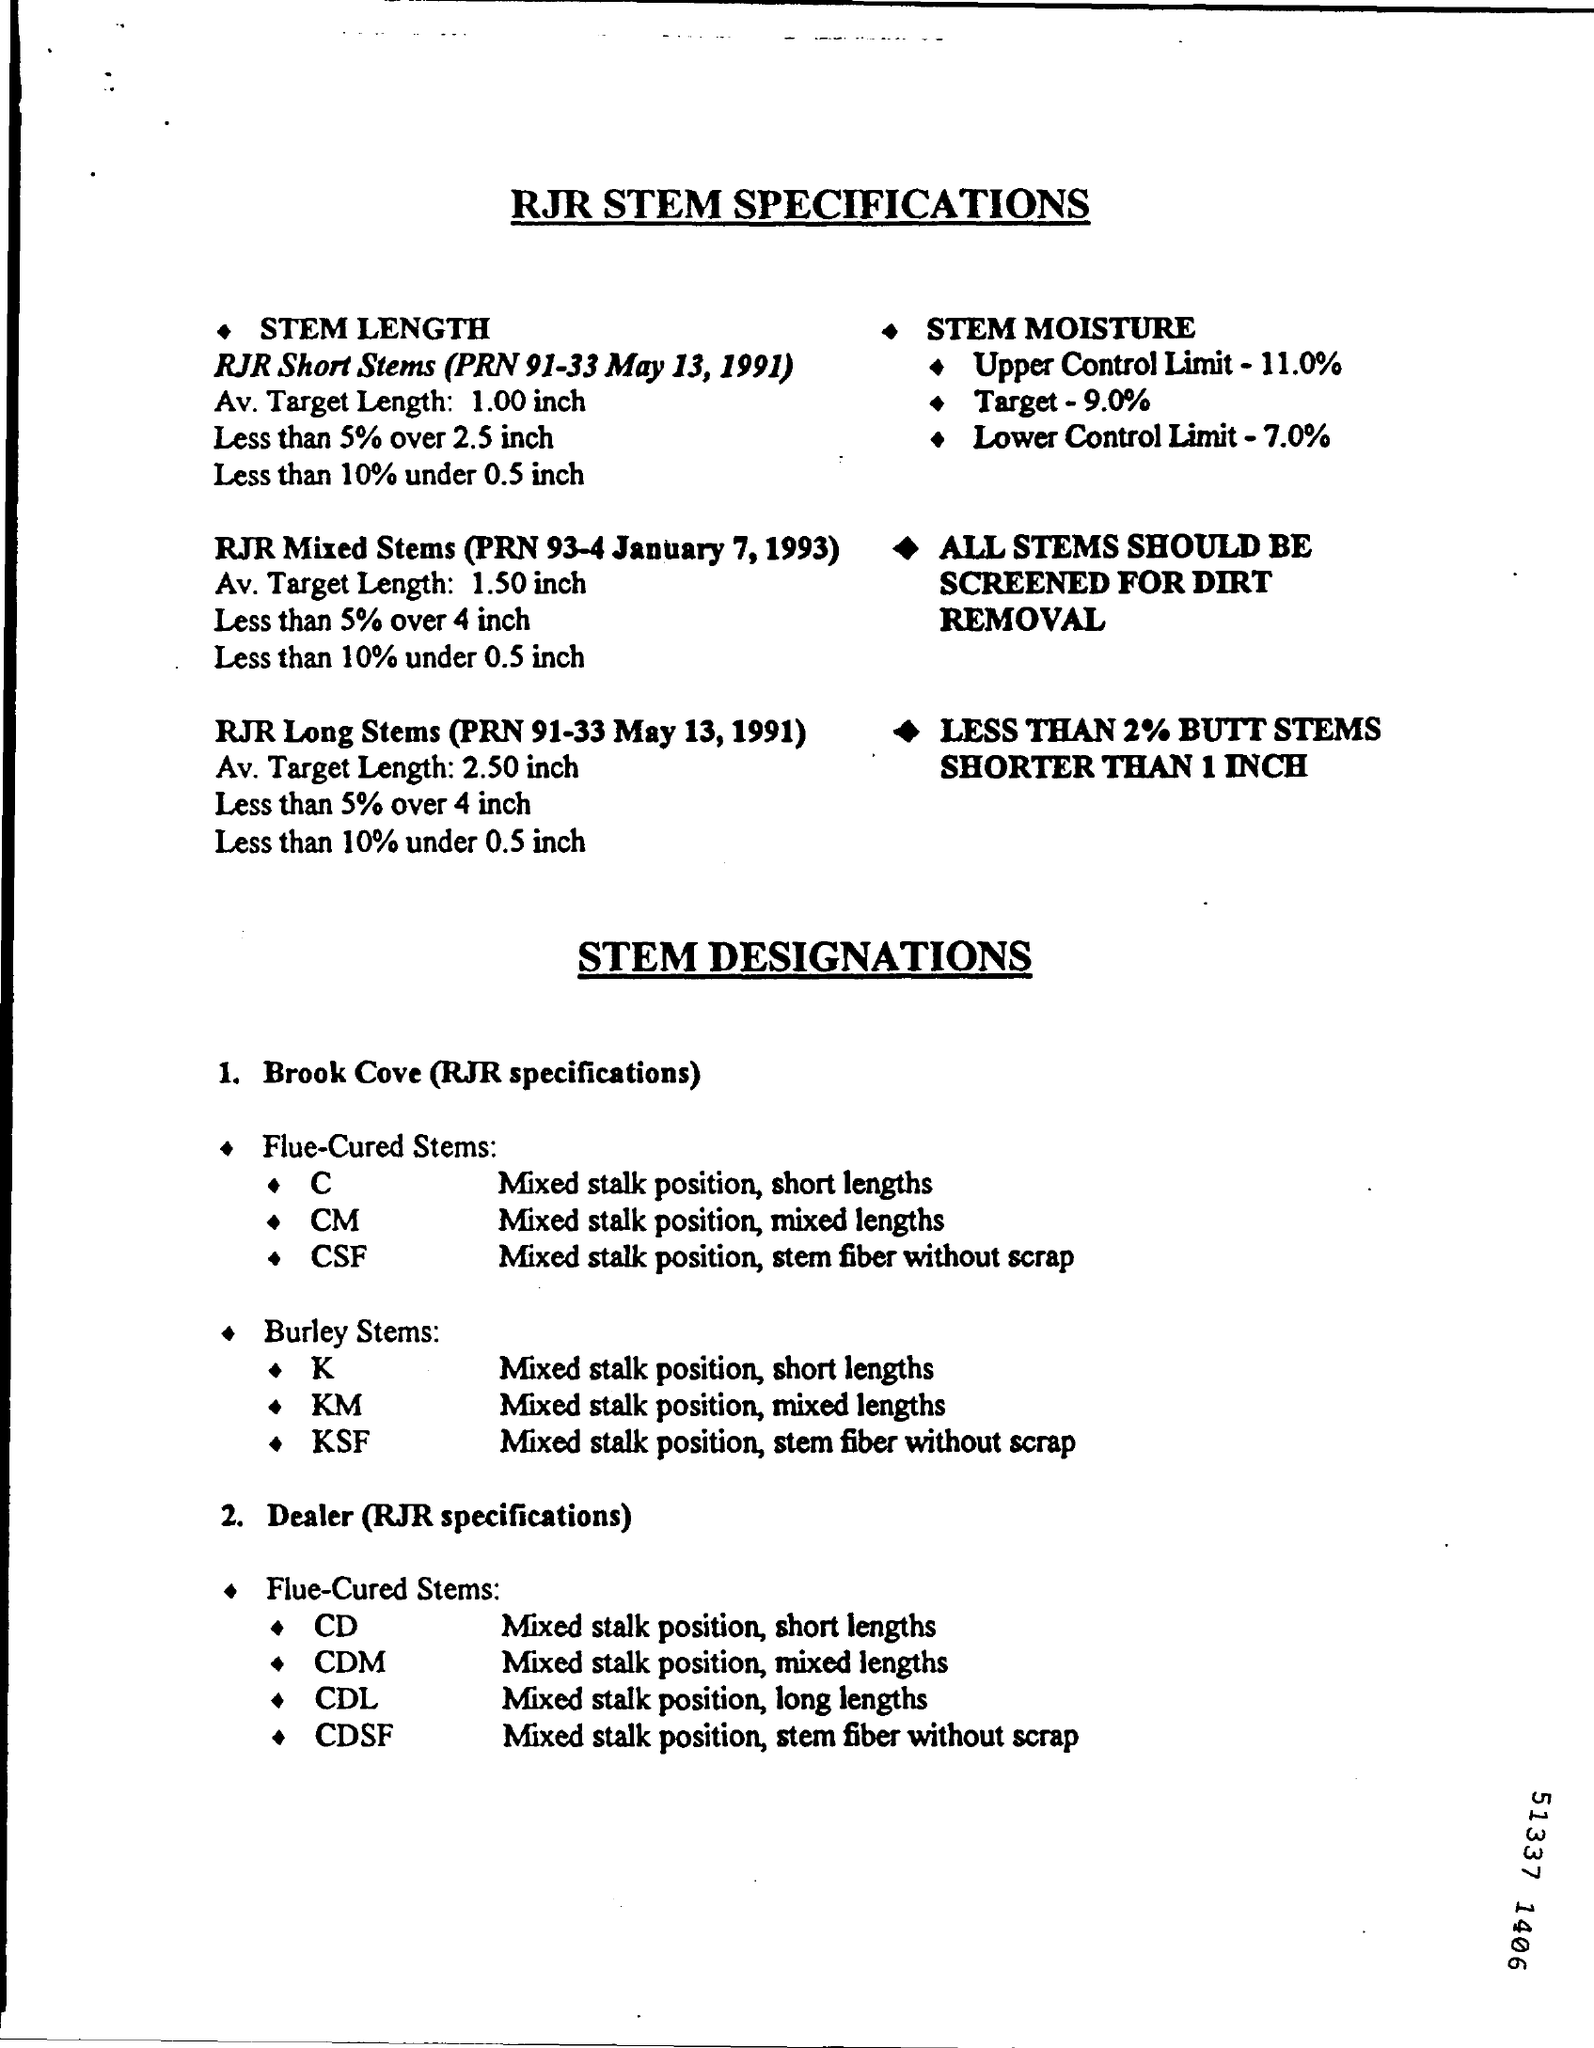What is the document title?
Offer a very short reply. RJR stem specifications. What was the Upper Control Limit of STEM MOISTURE?
Offer a terse response. 11.0%. What is the RJR specification for Brook Cove Flue-Cured Stems C?
Provide a succinct answer. Mixed stalk position, short lengths. What is the RJR specification for Burley Stems KM?
Your answer should be compact. Mixed stalk position, mixed lengths. 